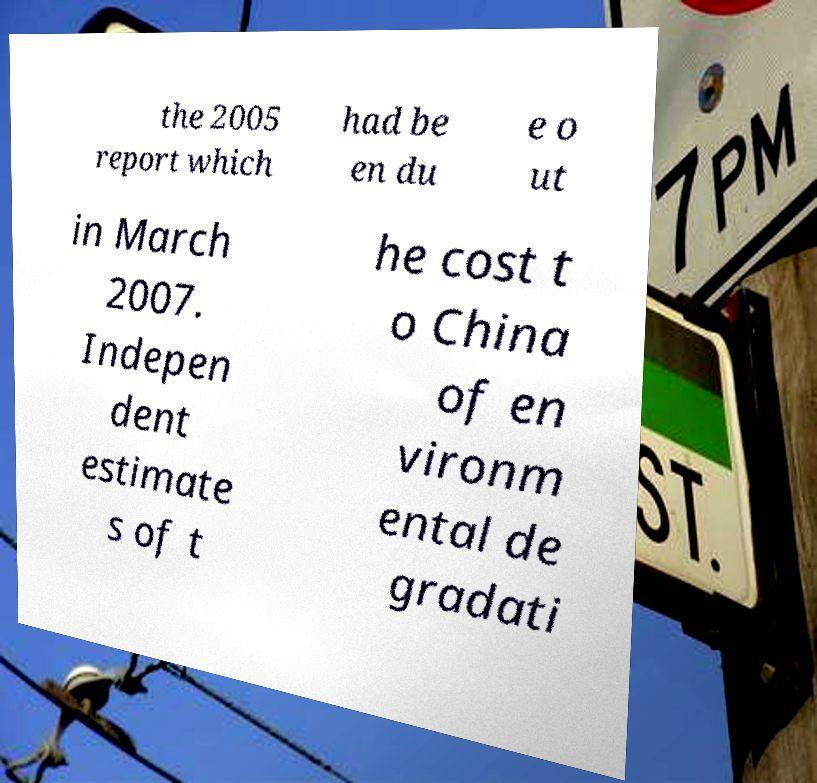For documentation purposes, I need the text within this image transcribed. Could you provide that? the 2005 report which had be en du e o ut in March 2007. Indepen dent estimate s of t he cost t o China of en vironm ental de gradati 